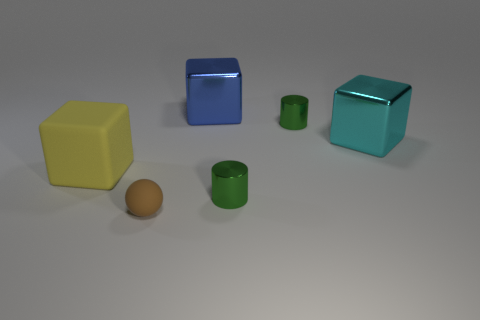What textures are visible in the objects present in this scene? The objects showcase a mix of textures: the matte finish of the brown ball, the rough or slightly grainy texture of the yellow cube, and the smooth, reflective metallic surfaces of the other geometric shapes. 